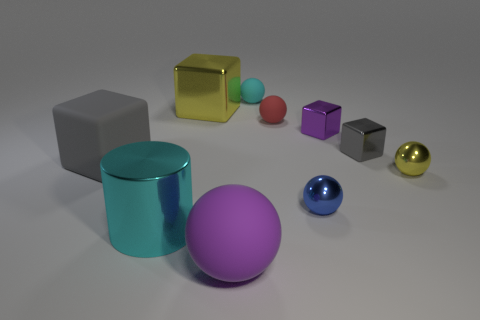Is the color of the matte block the same as the tiny cube to the right of the purple metallic object?
Offer a terse response. Yes. How many other objects are there of the same color as the large shiny block?
Provide a succinct answer. 1. Do the purple thing in front of the purple shiny block and the cyan object that is behind the big yellow cube have the same size?
Keep it short and to the point. No. There is a small object that is right of the gray shiny block; what is its color?
Make the answer very short. Yellow. Are there fewer gray rubber things that are on the right side of the small purple block than tiny gray matte spheres?
Your response must be concise. No. Do the small red ball and the cyan ball have the same material?
Provide a short and direct response. Yes. There is a purple thing that is the same shape as the tiny red rubber object; what is its size?
Your answer should be compact. Large. How many things are matte objects behind the cyan metal cylinder or yellow metallic objects in front of the red ball?
Your answer should be compact. 4. Are there fewer rubber blocks than yellow things?
Make the answer very short. Yes. Does the purple metal thing have the same size as the yellow object in front of the gray matte thing?
Your response must be concise. Yes. 